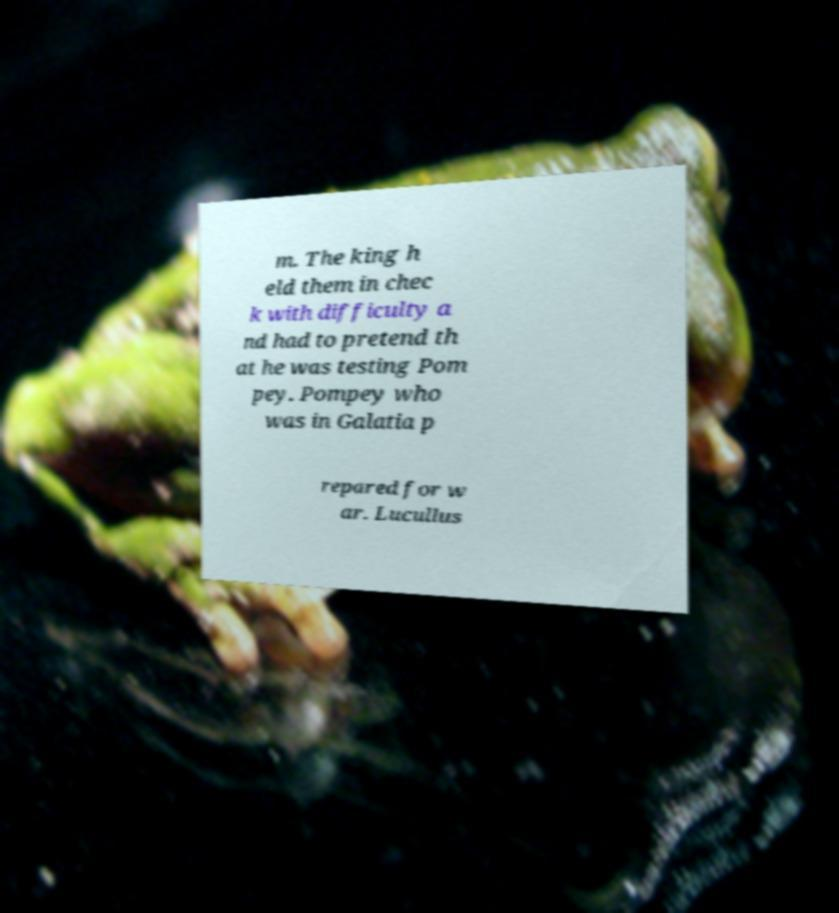Can you accurately transcribe the text from the provided image for me? m. The king h eld them in chec k with difficulty a nd had to pretend th at he was testing Pom pey. Pompey who was in Galatia p repared for w ar. Lucullus 